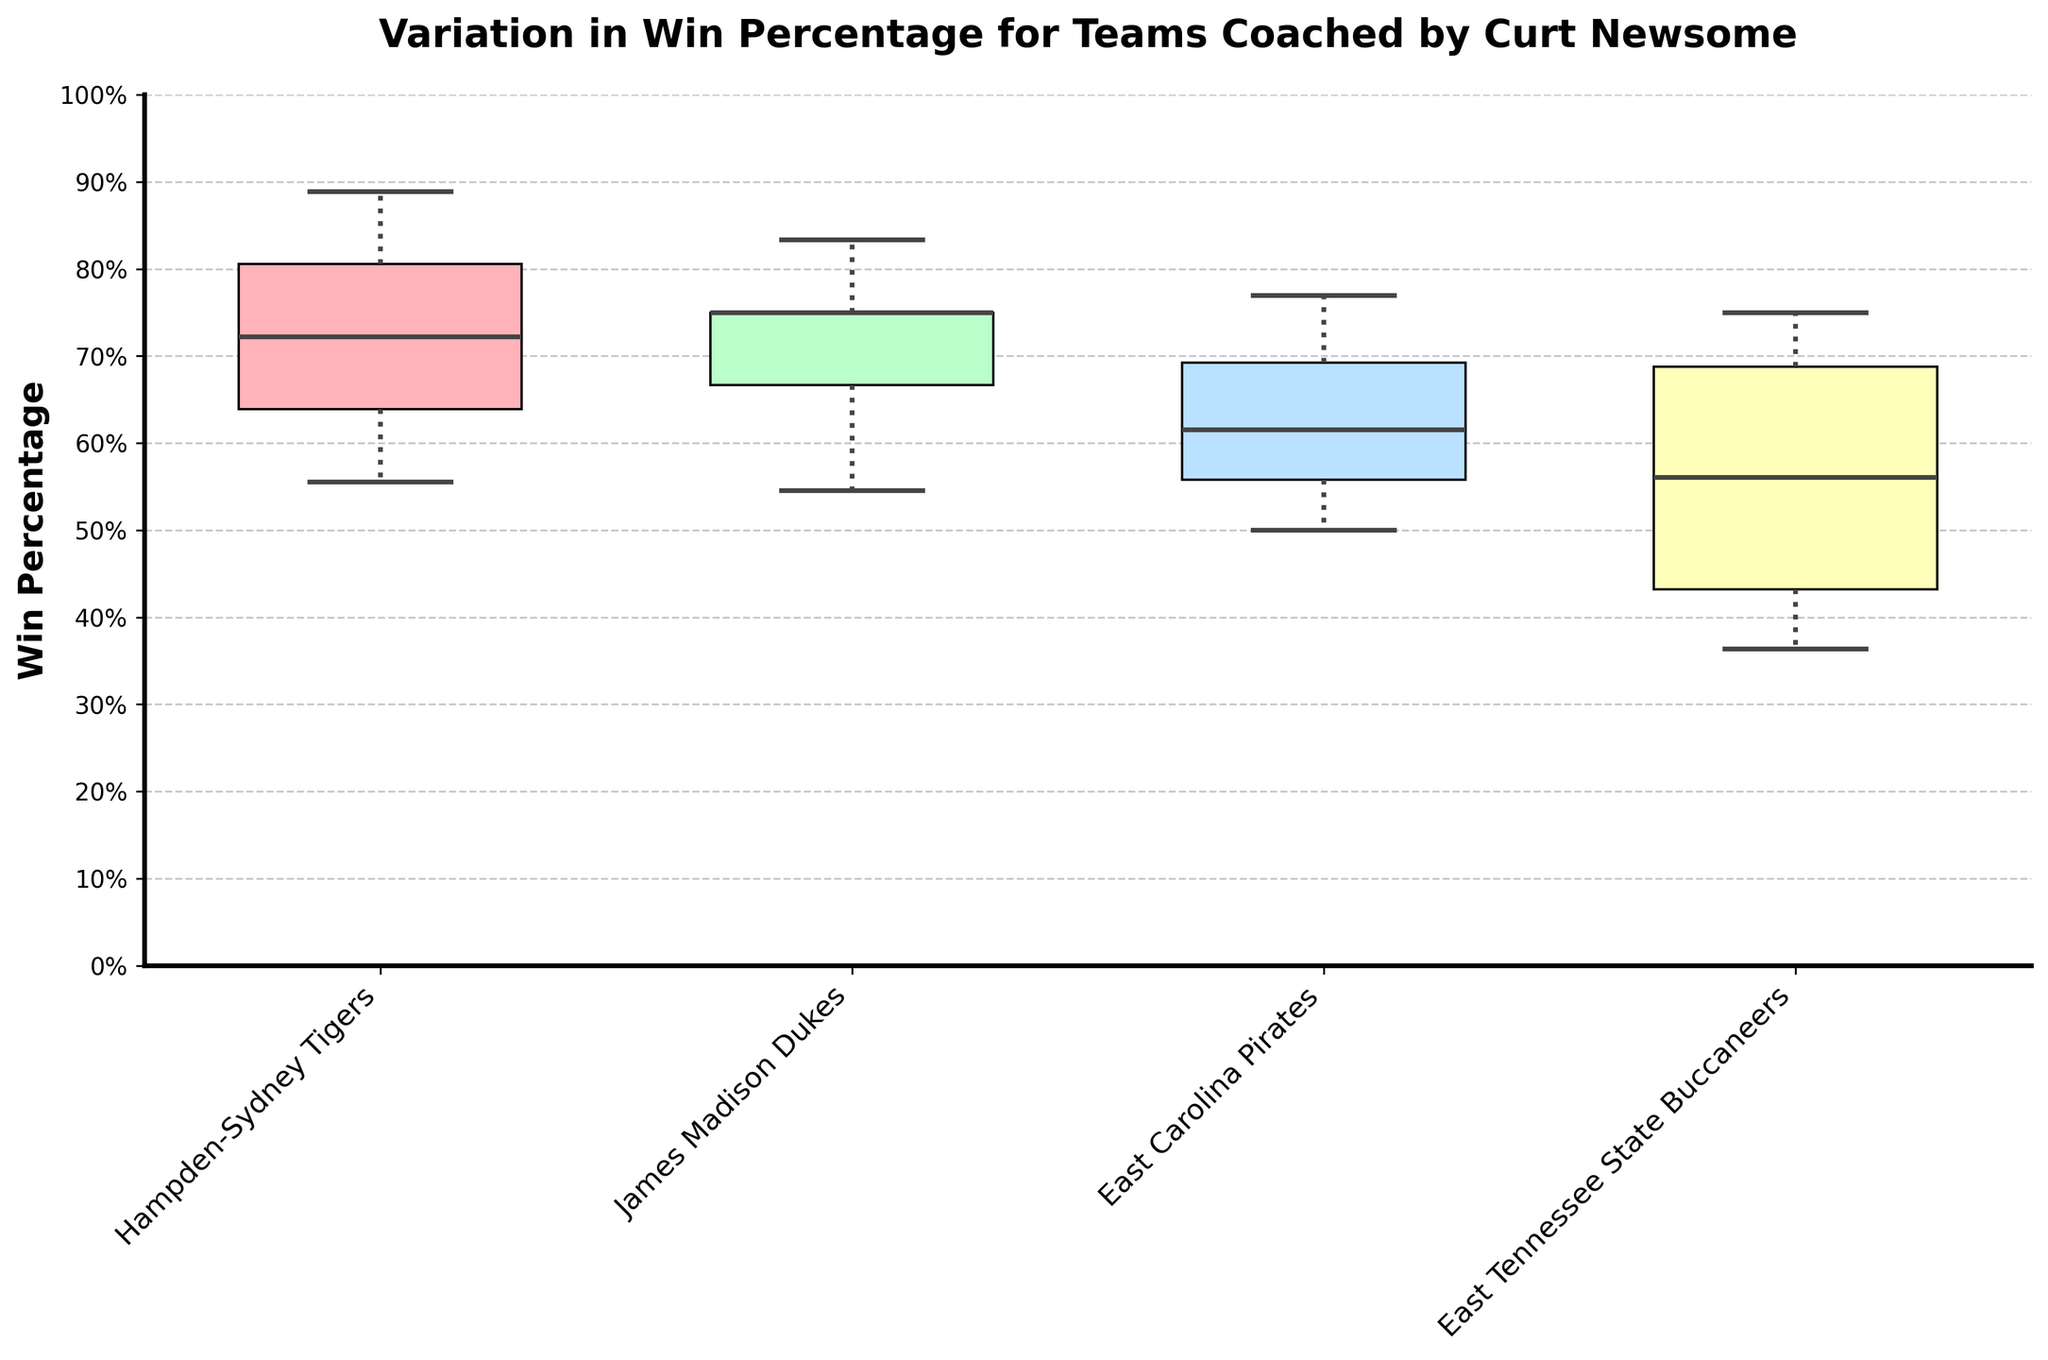what is the first team listed on the horizontal axis? The teams are listed on the horizontal axis starting from the left. The first team is Hampden-Sydney Tigers.
Answer: Hampden-Sydney Tigers What is the range of win percentages for the East Carolina Pirates? A box plot's range is determined by the distance between the minimum and maximum whiskers. The East Carolina Pirates' win percentage ranges from the lowest whisker to the highest whisker.
Answer: Approximately 50% to 100% Which team has the median win percentage closest to 80%? To find the median win percentage, look for the horizontal line inside the box plot for each team. The James Madison Dukes have a median line closest to 80%.
Answer: James Madison Dukes How do the win percentages of East Tennessee State Buccaneers compare to other teams? East Tennessee State Buccaneers' performance can be compared by looking at the position of their box plot relative to others. Their median and overall distribution is generally lower than Hampden-Sydney Tigers and James Madison Dukes but similar to East Carolina Pirates.
Answer: Generally lower than Hampden-Sydney Tigers and James Madison Dukes, similar to East Carolina Pirates Which team has the widest variation in win percentages? The team with the widest box (the interquartile range, IQR) has the most variation. The East Carolina Pirates have the widest IQR, indicating the most variation in win percentages.
Answer: East Carolina Pirates Does any team have a win percentage of exactly or close to 100%? We look for the whisker or flier that reaches the top of the plot, at a 100% mark. The James Madison Dukes have a top whisker near 100%.
Answer: James Madison Dukes What does the title of the plot indicate? The title gives an overview of the data presented. It indicates that the plot shows the variation in win percentages for teams coached by Curt Newsome.
Answer: Variation in Win Percentage for Teams Coached by Curt Newsome Which team has the lowest median win percentage? The median is shown by the line within each box plot. The East Tennessee State Buccaneers have the lowest median win percentage.
Answer: East Tennessee State Buccaneers 